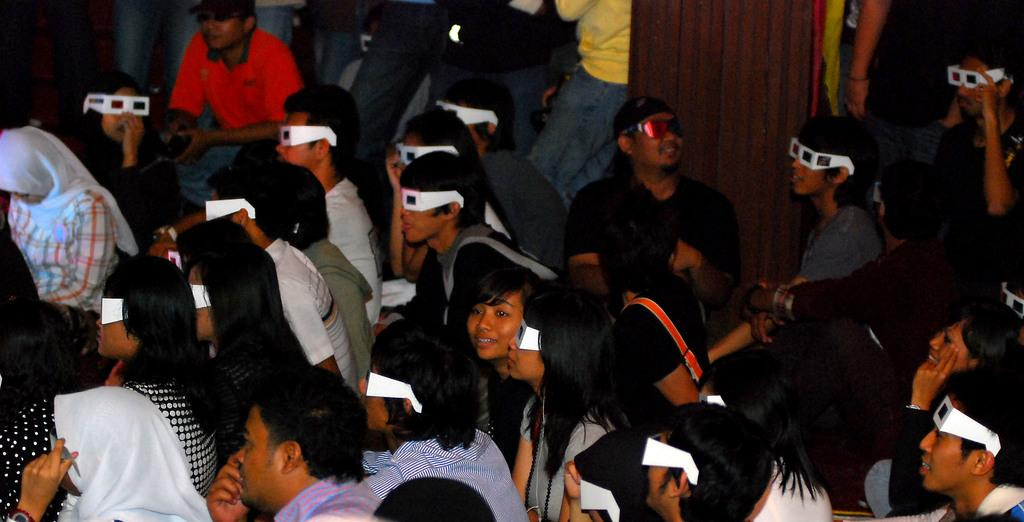How many people are in the image? There is a group of people in the image. What are the people in the image doing? Some people are standing, while others are sitting. What type of accessory can be seen on some of the people? There are persons wearing 3D glasses. What is the color and material of the wall in the background? The background of the image includes a wooden wall in brown color. What type of pollution can be seen in the image? There is no pollution visible in the image; it features a group of people with some wearing 3D glasses and a wooden wall in the background. 